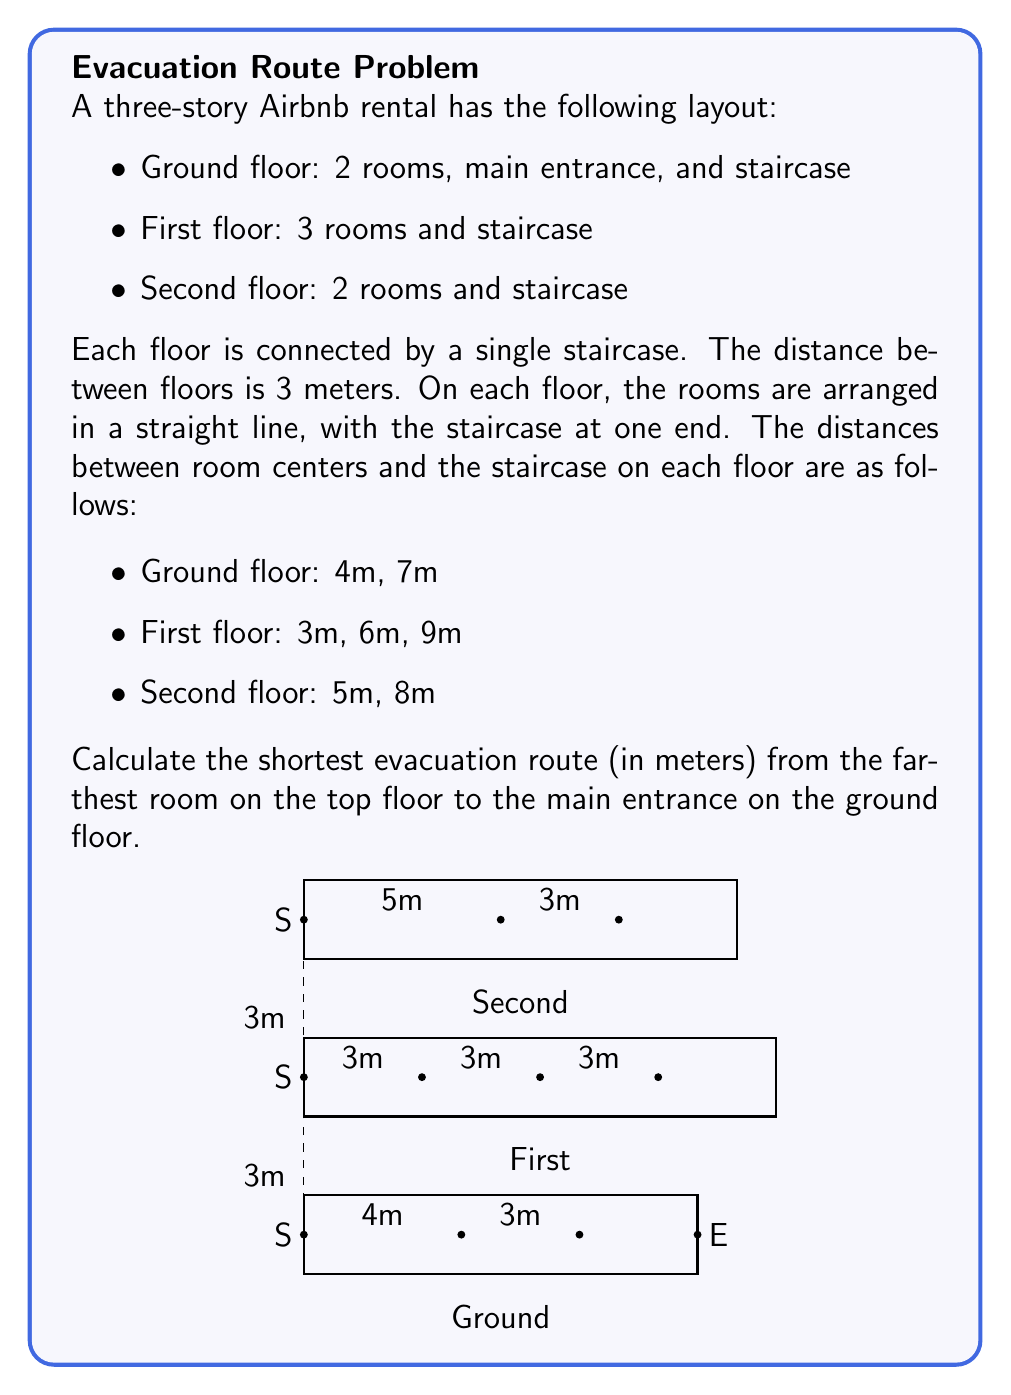Can you solve this math problem? To find the shortest evacuation route, we need to calculate the distance from the farthest room on the top floor to the main entrance. This involves three components:

1. Horizontal distance on the top floor (second floor)
2. Vertical distance down the stairs
3. Horizontal distance on the ground floor

Let's calculate each component:

1. Horizontal distance on the second floor:
   The farthest room is 8m from the staircase.

2. Vertical distance down the stairs:
   There are two floors to descend, each 3m high.
   Total vertical distance = $2 \times 3\text{m} = 6\text{m}$

3. Horizontal distance on the ground floor:
   The staircase is at one end, and the main entrance is at the other end.
   This distance is 10m (4m + 3m + 3m).

To calculate the total distance, we need to use the Pythagorean theorem to combine the vertical and horizontal components:

Let $x$ be the horizontal distance and $y$ be the vertical distance.

$x = 8\text{m} + 10\text{m} = 18\text{m}$ (total horizontal distance)
$y = 6\text{m}$ (total vertical distance)

The shortest path (hypotenuse) is given by:

$$ d = \sqrt{x^2 + y^2} = \sqrt{18^2 + 6^2} = \sqrt{324 + 36} = \sqrt{360} = 6\sqrt{10} \approx 18.97\text{m} $$

Therefore, the shortest evacuation route is approximately 18.97 meters.
Answer: $6\sqrt{10} \approx 18.97\text{m}$ 